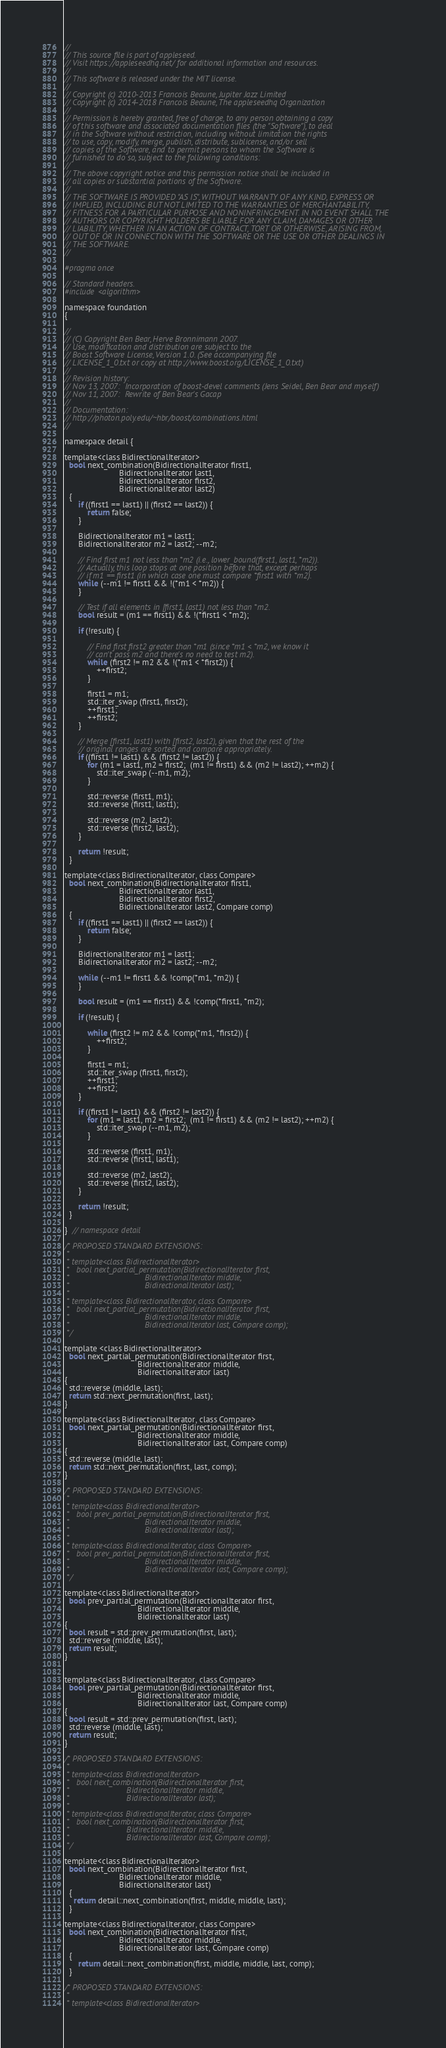<code> <loc_0><loc_0><loc_500><loc_500><_C_>
//
// This source file is part of appleseed.
// Visit https://appleseedhq.net/ for additional information and resources.
//
// This software is released under the MIT license.
//
// Copyright (c) 2010-2013 Francois Beaune, Jupiter Jazz Limited
// Copyright (c) 2014-2018 Francois Beaune, The appleseedhq Organization
//
// Permission is hereby granted, free of charge, to any person obtaining a copy
// of this software and associated documentation files (the "Software"), to deal
// in the Software without restriction, including without limitation the rights
// to use, copy, modify, merge, publish, distribute, sublicense, and/or sell
// copies of the Software, and to permit persons to whom the Software is
// furnished to do so, subject to the following conditions:
//
// The above copyright notice and this permission notice shall be included in
// all copies or substantial portions of the Software.
//
// THE SOFTWARE IS PROVIDED "AS IS", WITHOUT WARRANTY OF ANY KIND, EXPRESS OR
// IMPLIED, INCLUDING BUT NOT LIMITED TO THE WARRANTIES OF MERCHANTABILITY,
// FITNESS FOR A PARTICULAR PURPOSE AND NONINFRINGEMENT. IN NO EVENT SHALL THE
// AUTHORS OR COPYRIGHT HOLDERS BE LIABLE FOR ANY CLAIM, DAMAGES OR OTHER
// LIABILITY, WHETHER IN AN ACTION OF CONTRACT, TORT OR OTHERWISE, ARISING FROM,
// OUT OF OR IN CONNECTION WITH THE SOFTWARE OR THE USE OR OTHER DEALINGS IN
// THE SOFTWARE.
//

#pragma once

// Standard headers.
#include <algorithm>

namespace foundation
{

//
// (C) Copyright Ben Bear, Herve Bronnimann 2007.
// Use, modification and distribution are subject to the
// Boost Software License, Version 1.0. (See accompanying file
// LICENSE_1_0.txt or copy at http://www.boost.org/LICENSE_1_0.txt)
//
// Revision history:
// Nov 13, 2007:  Incorporation of boost-devel comments (Jens Seidel, Ben Bear and myself)
// Nov 11, 2007:  Rewrite of Ben Bear's Gacap
//
// Documentation:
// http://photon.poly.edu/~hbr/boost/combinations.html
//

namespace detail {

template<class BidirectionalIterator> 
  bool next_combination(BidirectionalIterator first1,
                        BidirectionalIterator last1,
                        BidirectionalIterator first2,
                        BidirectionalIterator last2)
  {
      if ((first1 == last1) || (first2 == last2)) {
          return false;
      }
      
      BidirectionalIterator m1 = last1;
      BidirectionalIterator m2 = last2; --m2;
      
      // Find first m1 not less than *m2 (i.e., lower_bound(first1, last1, *m2)).
      // Actually, this loop stops at one position before that, except perhaps
      // if m1 == first1 (in which case one must compare *first1 with *m2).
      while (--m1 != first1 && !(*m1 < *m2)) {
      }
      
      // Test if all elements in [first1, last1) not less than *m2.
      bool result = (m1 == first1) && !(*first1 < *m2);
      
      if (!result) {

          // Find first first2 greater than *m1 (since *m1 < *m2, we know it
          // can't pass m2 and there's no need to test m2).
          while (first2 != m2 && !(*m1 < *first2)) {
              ++first2;
          }
          
          first1 = m1;
          std::iter_swap (first1, first2);
          ++first1;
          ++first2;
      }
      
      // Merge [first1, last1) with [first2, last2), given that the rest of the
      // original ranges are sorted and compare appropriately.
      if ((first1 != last1) && (first2 != last2)) {      
          for (m1 = last1, m2 = first2;  (m1 != first1) && (m2 != last2); ++m2) {
              std::iter_swap (--m1, m2);
          }
          
          std::reverse (first1, m1);
          std::reverse (first1, last1);
          
          std::reverse (m2, last2);
          std::reverse (first2, last2);
      }
      
      return !result;
  }
    
template<class BidirectionalIterator, class Compare> 
  bool next_combination(BidirectionalIterator first1,
                        BidirectionalIterator last1,
                        BidirectionalIterator first2,
                        BidirectionalIterator last2, Compare comp)
  {
      if ((first1 == last1) || (first2 == last2)) {
          return false;
      }
      
      BidirectionalIterator m1 = last1;
      BidirectionalIterator m2 = last2; --m2;
      
      while (--m1 != first1 && !comp(*m1, *m2)) {
      }
      
      bool result = (m1 == first1) && !comp(*first1, *m2);
      
      if (!result) {
          
          while (first2 != m2 && !comp(*m1, *first2)) {
              ++first2;
          }

          first1 = m1; 
          std::iter_swap (first1, first2);
          ++first1;
          ++first2;
      }
      
      if ((first1 != last1) && (first2 != last2)) {      
          for (m1 = last1, m2 = first2;  (m1 != first1) && (m2 != last2); ++m2) {
              std::iter_swap (--m1, m2);
          }
          
          std::reverse (first1, m1);
          std::reverse (first1, last1);
          
          std::reverse (m2, last2);
          std::reverse (first2, last2);
      }
      
      return !result;
  }
  
}  // namespace detail

/* PROPOSED STANDARD EXTENSIONS:
 *
 * template<class BidirectionalIterator> 
 *   bool next_partial_permutation(BidirectionalIterator first,
 *                                 BidirectionalIterator middle,
 *                                 BidirectionalIterator last); 
 *
 * template<class BidirectionalIterator, class Compare> 
 *   bool next_partial_permutation(BidirectionalIterator first,
 *                                 BidirectionalIterator middle,
 *                                 BidirectionalIterator last, Compare comp); 
 */
 
template <class BidirectionalIterator>
  bool next_partial_permutation(BidirectionalIterator first,
                                BidirectionalIterator middle,
                                BidirectionalIterator last)
{
  std::reverse (middle, last);
  return std::next_permutation(first, last);
}

template<class BidirectionalIterator, class Compare> 
  bool next_partial_permutation(BidirectionalIterator first,
                                BidirectionalIterator middle,
                                BidirectionalIterator last, Compare comp)
{
  std::reverse (middle, last);
  return std::next_permutation(first, last, comp);
}

/* PROPOSED STANDARD EXTENSIONS:
 *
 * template<class BidirectionalIterator> 
 *   bool prev_partial_permutation(BidirectionalIterator first,
 *                                 BidirectionalIterator middle,
 *                                 BidirectionalIterator last); 
 *
 * template<class BidirectionalIterator, class Compare> 
 *   bool prev_partial_permutation(BidirectionalIterator first,
 *                                 BidirectionalIterator middle,
 *                                 BidirectionalIterator last, Compare comp); 
 */
 
template<class BidirectionalIterator> 
  bool prev_partial_permutation(BidirectionalIterator first,
                                BidirectionalIterator middle,
                                BidirectionalIterator last)
{
  bool result = std::prev_permutation(first, last);
  std::reverse (middle, last);
  return result;
}


template<class BidirectionalIterator, class Compare> 
  bool prev_partial_permutation(BidirectionalIterator first,
                                BidirectionalIterator middle,
                                BidirectionalIterator last, Compare comp)
{
  bool result = std::prev_permutation(first, last);
  std::reverse (middle, last);
  return result;
}

/* PROPOSED STANDARD EXTENSIONS:
 *
 * template<class BidirectionalIterator> 
 *   bool next_combination(BidirectionalIterator first,
 *                         BidirectionalIterator middle,
 *                         BidirectionalIterator last); 
 *
 * template<class BidirectionalIterator, class Compare> 
 *   bool next_combination(BidirectionalIterator first,
 *                         BidirectionalIterator middle,
 *                         BidirectionalIterator last, Compare comp); 
 */

template<class BidirectionalIterator> 
  bool next_combination(BidirectionalIterator first,
                        BidirectionalIterator middle,
                        BidirectionalIterator last)
  {
    return detail::next_combination(first, middle, middle, last);
  }
    
template<class BidirectionalIterator, class Compare> 
  bool next_combination(BidirectionalIterator first,
                        BidirectionalIterator middle,
                        BidirectionalIterator last, Compare comp)
  {
      return detail::next_combination(first, middle, middle, last, comp);
  }
 
/* PROPOSED STANDARD EXTENSIONS:
 *
 * template<class BidirectionalIterator> </code> 